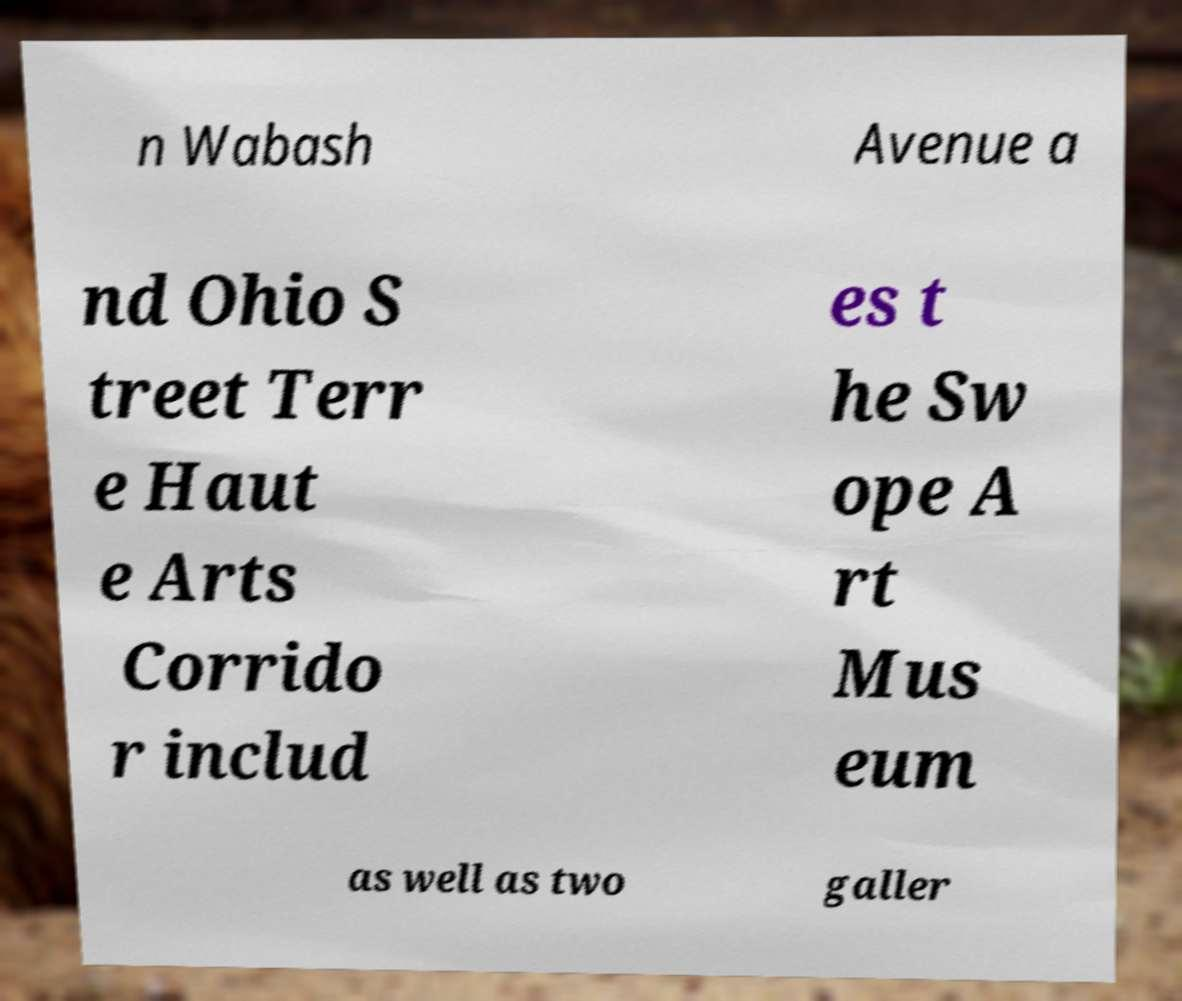For documentation purposes, I need the text within this image transcribed. Could you provide that? n Wabash Avenue a nd Ohio S treet Terr e Haut e Arts Corrido r includ es t he Sw ope A rt Mus eum as well as two galler 